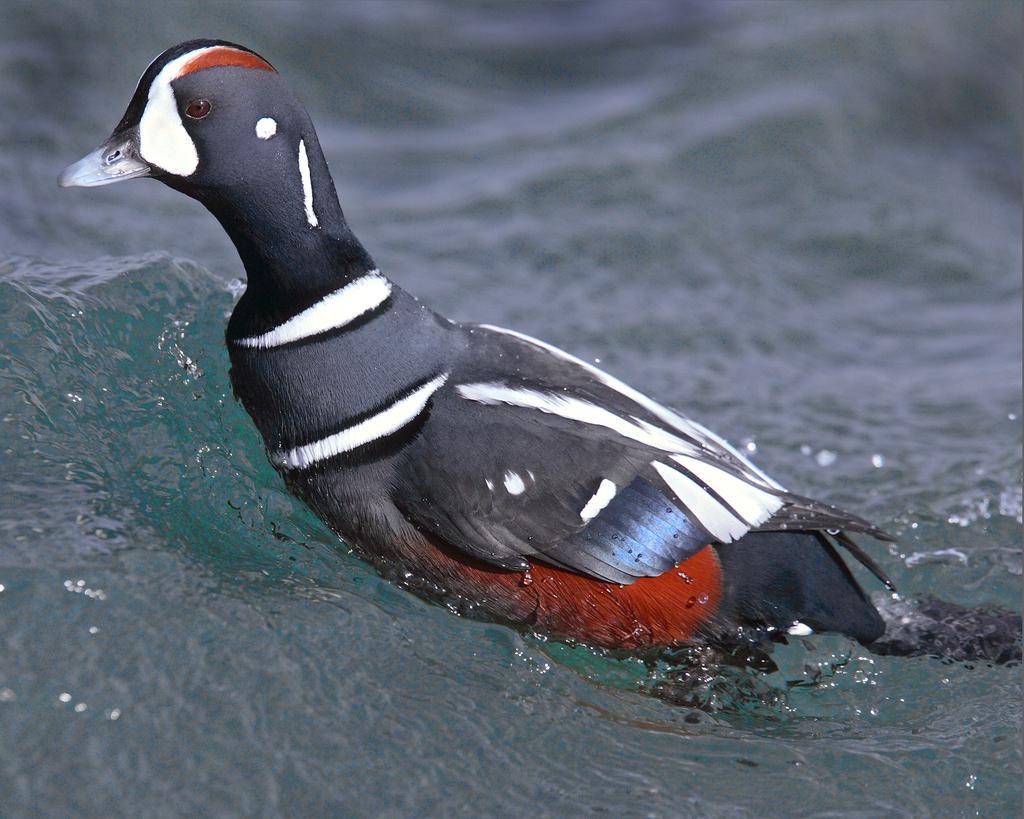Could you give a brief overview of what you see in this image? In this image in the center there is a bird in the water. 